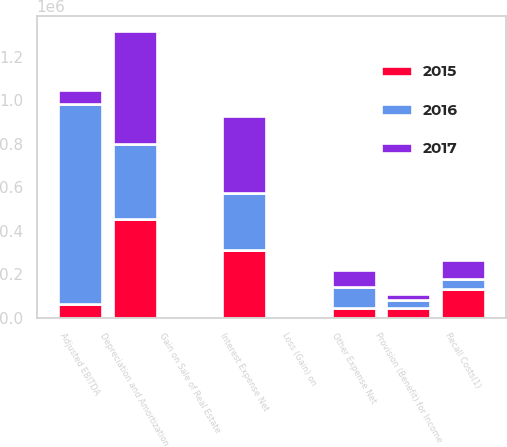Convert chart to OTSL. <chart><loc_0><loc_0><loc_500><loc_500><stacked_bar_chart><ecel><fcel>Adjusted EBITDA<fcel>Gain on Sale of Real Estate<fcel>Provision (Benefit) for Income<fcel>Other Expense Net<fcel>Interest Expense Net<fcel>Loss (Gain) on<fcel>Depreciation and Amortization<fcel>Recall Costs(1)<nl><fcel>2016<fcel>920005<fcel>850<fcel>37713<fcel>98590<fcel>263871<fcel>3000<fcel>345464<fcel>47014<nl><fcel>2015<fcel>63221.5<fcel>2180<fcel>44944<fcel>44300<fcel>310662<fcel>1412<fcel>452326<fcel>131944<nl><fcel>2017<fcel>63221.5<fcel>1565<fcel>25947<fcel>79429<fcel>353575<fcel>799<fcel>522376<fcel>84901<nl></chart> 